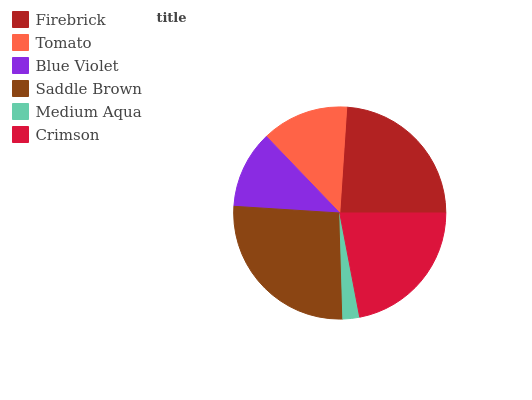Is Medium Aqua the minimum?
Answer yes or no. Yes. Is Saddle Brown the maximum?
Answer yes or no. Yes. Is Tomato the minimum?
Answer yes or no. No. Is Tomato the maximum?
Answer yes or no. No. Is Firebrick greater than Tomato?
Answer yes or no. Yes. Is Tomato less than Firebrick?
Answer yes or no. Yes. Is Tomato greater than Firebrick?
Answer yes or no. No. Is Firebrick less than Tomato?
Answer yes or no. No. Is Crimson the high median?
Answer yes or no. Yes. Is Tomato the low median?
Answer yes or no. Yes. Is Firebrick the high median?
Answer yes or no. No. Is Saddle Brown the low median?
Answer yes or no. No. 